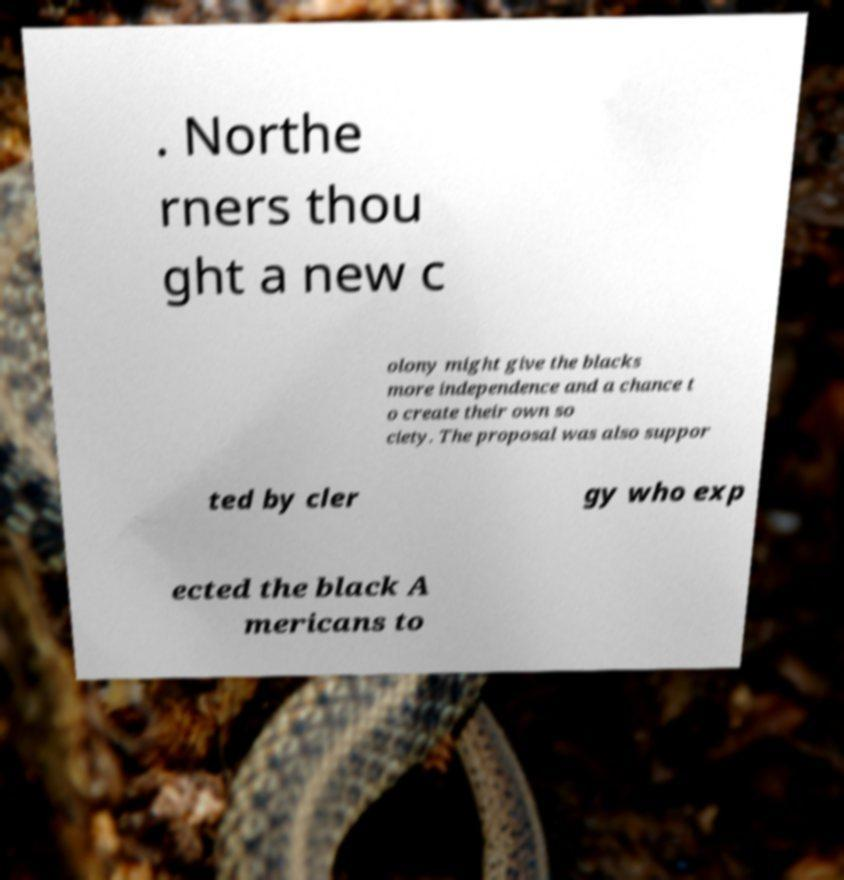There's text embedded in this image that I need extracted. Can you transcribe it verbatim? . Northe rners thou ght a new c olony might give the blacks more independence and a chance t o create their own so ciety. The proposal was also suppor ted by cler gy who exp ected the black A mericans to 